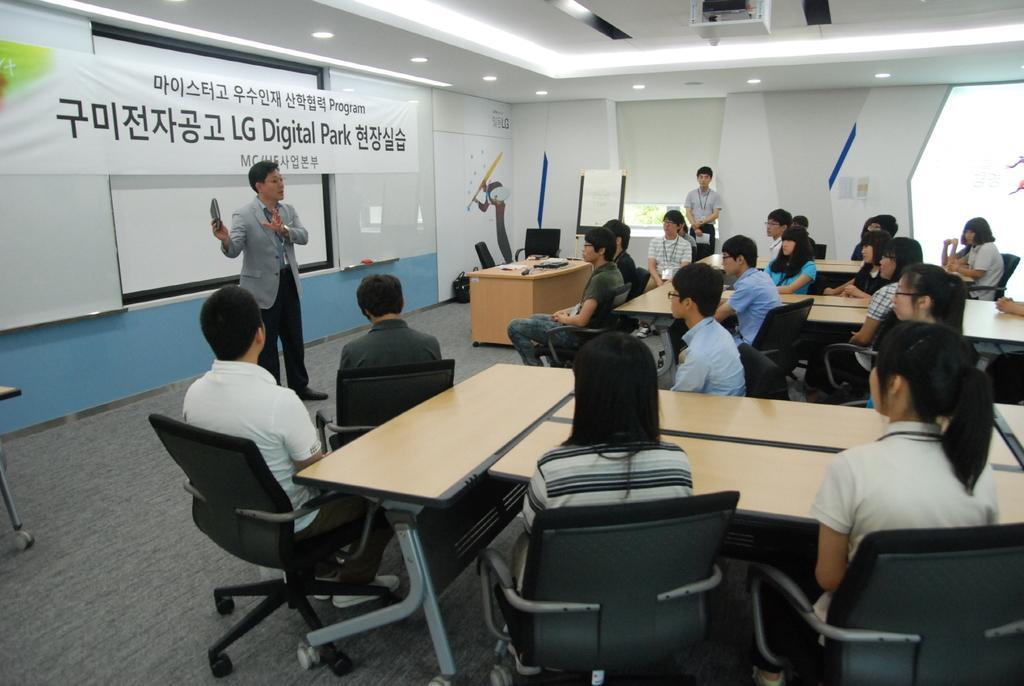Can you describe this image briefly? The person wearing suit is standing and speaking in front of a group of people and there is a banner behind him which has lg digital park written on it. 